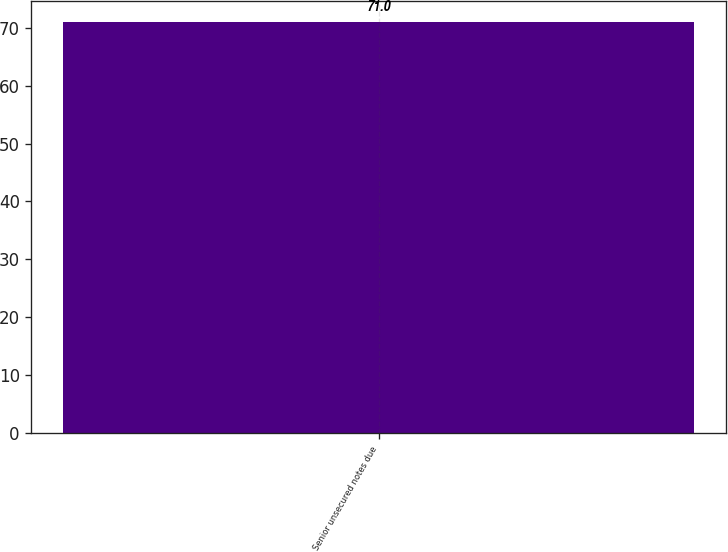Convert chart. <chart><loc_0><loc_0><loc_500><loc_500><bar_chart><fcel>Senior unsecured notes due<nl><fcel>71<nl></chart> 